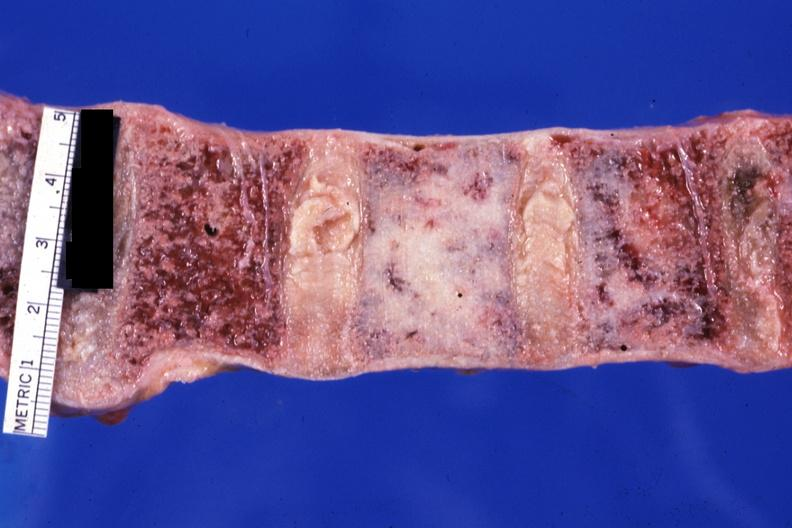what is a case of prostatic carcinoma?
Answer the question using a single word or phrase. This 